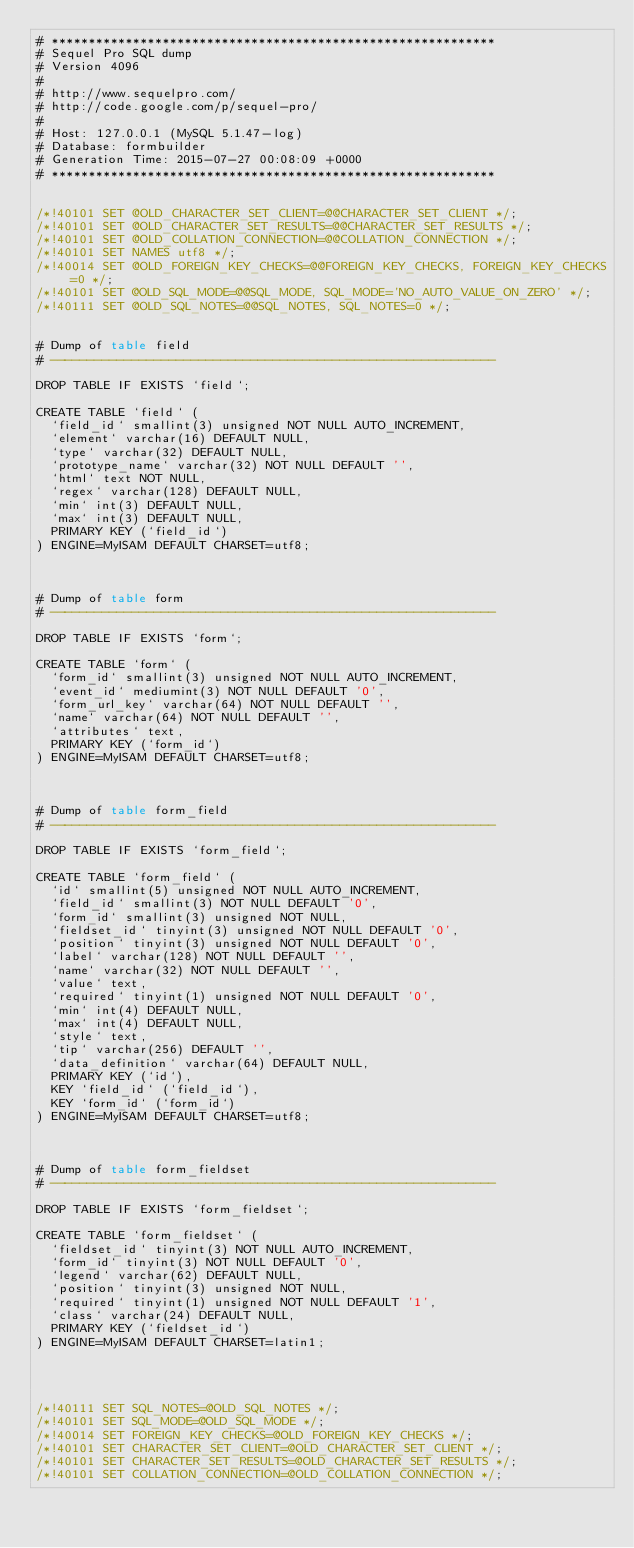<code> <loc_0><loc_0><loc_500><loc_500><_SQL_># ************************************************************
# Sequel Pro SQL dump
# Version 4096
#
# http://www.sequelpro.com/
# http://code.google.com/p/sequel-pro/
#
# Host: 127.0.0.1 (MySQL 5.1.47-log)
# Database: formbuilder
# Generation Time: 2015-07-27 00:08:09 +0000
# ************************************************************


/*!40101 SET @OLD_CHARACTER_SET_CLIENT=@@CHARACTER_SET_CLIENT */;
/*!40101 SET @OLD_CHARACTER_SET_RESULTS=@@CHARACTER_SET_RESULTS */;
/*!40101 SET @OLD_COLLATION_CONNECTION=@@COLLATION_CONNECTION */;
/*!40101 SET NAMES utf8 */;
/*!40014 SET @OLD_FOREIGN_KEY_CHECKS=@@FOREIGN_KEY_CHECKS, FOREIGN_KEY_CHECKS=0 */;
/*!40101 SET @OLD_SQL_MODE=@@SQL_MODE, SQL_MODE='NO_AUTO_VALUE_ON_ZERO' */;
/*!40111 SET @OLD_SQL_NOTES=@@SQL_NOTES, SQL_NOTES=0 */;


# Dump of table field
# ------------------------------------------------------------

DROP TABLE IF EXISTS `field`;

CREATE TABLE `field` (
  `field_id` smallint(3) unsigned NOT NULL AUTO_INCREMENT,
  `element` varchar(16) DEFAULT NULL,
  `type` varchar(32) DEFAULT NULL,
  `prototype_name` varchar(32) NOT NULL DEFAULT '',
  `html` text NOT NULL,
  `regex` varchar(128) DEFAULT NULL,
  `min` int(3) DEFAULT NULL,
  `max` int(3) DEFAULT NULL,
  PRIMARY KEY (`field_id`)
) ENGINE=MyISAM DEFAULT CHARSET=utf8;



# Dump of table form
# ------------------------------------------------------------

DROP TABLE IF EXISTS `form`;

CREATE TABLE `form` (
  `form_id` smallint(3) unsigned NOT NULL AUTO_INCREMENT,
  `event_id` mediumint(3) NOT NULL DEFAULT '0',
  `form_url_key` varchar(64) NOT NULL DEFAULT '',
  `name` varchar(64) NOT NULL DEFAULT '',
  `attributes` text,
  PRIMARY KEY (`form_id`)
) ENGINE=MyISAM DEFAULT CHARSET=utf8;



# Dump of table form_field
# ------------------------------------------------------------

DROP TABLE IF EXISTS `form_field`;

CREATE TABLE `form_field` (
  `id` smallint(5) unsigned NOT NULL AUTO_INCREMENT,
  `field_id` smallint(3) NOT NULL DEFAULT '0',
  `form_id` smallint(3) unsigned NOT NULL,
  `fieldset_id` tinyint(3) unsigned NOT NULL DEFAULT '0',
  `position` tinyint(3) unsigned NOT NULL DEFAULT '0',
  `label` varchar(128) NOT NULL DEFAULT '',
  `name` varchar(32) NOT NULL DEFAULT '',
  `value` text,
  `required` tinyint(1) unsigned NOT NULL DEFAULT '0',
  `min` int(4) DEFAULT NULL,
  `max` int(4) DEFAULT NULL,
  `style` text,
  `tip` varchar(256) DEFAULT '',
  `data_definition` varchar(64) DEFAULT NULL,
  PRIMARY KEY (`id`),
  KEY `field_id` (`field_id`),
  KEY `form_id` (`form_id`)
) ENGINE=MyISAM DEFAULT CHARSET=utf8;



# Dump of table form_fieldset
# ------------------------------------------------------------

DROP TABLE IF EXISTS `form_fieldset`;

CREATE TABLE `form_fieldset` (
  `fieldset_id` tinyint(3) NOT NULL AUTO_INCREMENT,
  `form_id` tinyint(3) NOT NULL DEFAULT '0',
  `legend` varchar(62) DEFAULT NULL,
  `position` tinyint(3) unsigned NOT NULL,
  `required` tinyint(1) unsigned NOT NULL DEFAULT '1',
  `class` varchar(24) DEFAULT NULL,
  PRIMARY KEY (`fieldset_id`)
) ENGINE=MyISAM DEFAULT CHARSET=latin1;




/*!40111 SET SQL_NOTES=@OLD_SQL_NOTES */;
/*!40101 SET SQL_MODE=@OLD_SQL_MODE */;
/*!40014 SET FOREIGN_KEY_CHECKS=@OLD_FOREIGN_KEY_CHECKS */;
/*!40101 SET CHARACTER_SET_CLIENT=@OLD_CHARACTER_SET_CLIENT */;
/*!40101 SET CHARACTER_SET_RESULTS=@OLD_CHARACTER_SET_RESULTS */;
/*!40101 SET COLLATION_CONNECTION=@OLD_COLLATION_CONNECTION */;
</code> 